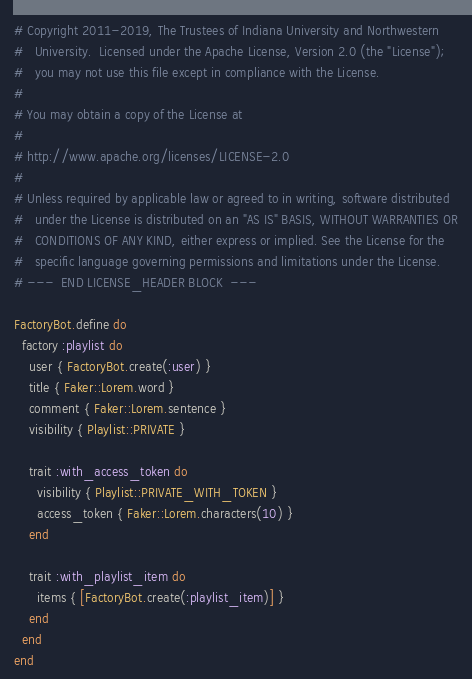Convert code to text. <code><loc_0><loc_0><loc_500><loc_500><_Ruby_># Copyright 2011-2019, The Trustees of Indiana University and Northwestern
#   University.  Licensed under the Apache License, Version 2.0 (the "License");
#   you may not use this file except in compliance with the License.
#
# You may obtain a copy of the License at
#
# http://www.apache.org/licenses/LICENSE-2.0
#
# Unless required by applicable law or agreed to in writing, software distributed
#   under the License is distributed on an "AS IS" BASIS, WITHOUT WARRANTIES OR
#   CONDITIONS OF ANY KIND, either express or implied. See the License for the
#   specific language governing permissions and limitations under the License.
# ---  END LICENSE_HEADER BLOCK  ---

FactoryBot.define do
  factory :playlist do
    user { FactoryBot.create(:user) }
    title { Faker::Lorem.word }
    comment { Faker::Lorem.sentence }
    visibility { Playlist::PRIVATE }

    trait :with_access_token do
      visibility { Playlist::PRIVATE_WITH_TOKEN }
      access_token { Faker::Lorem.characters(10) }
    end

    trait :with_playlist_item do
      items { [FactoryBot.create(:playlist_item)] }
    end
  end
end
</code> 